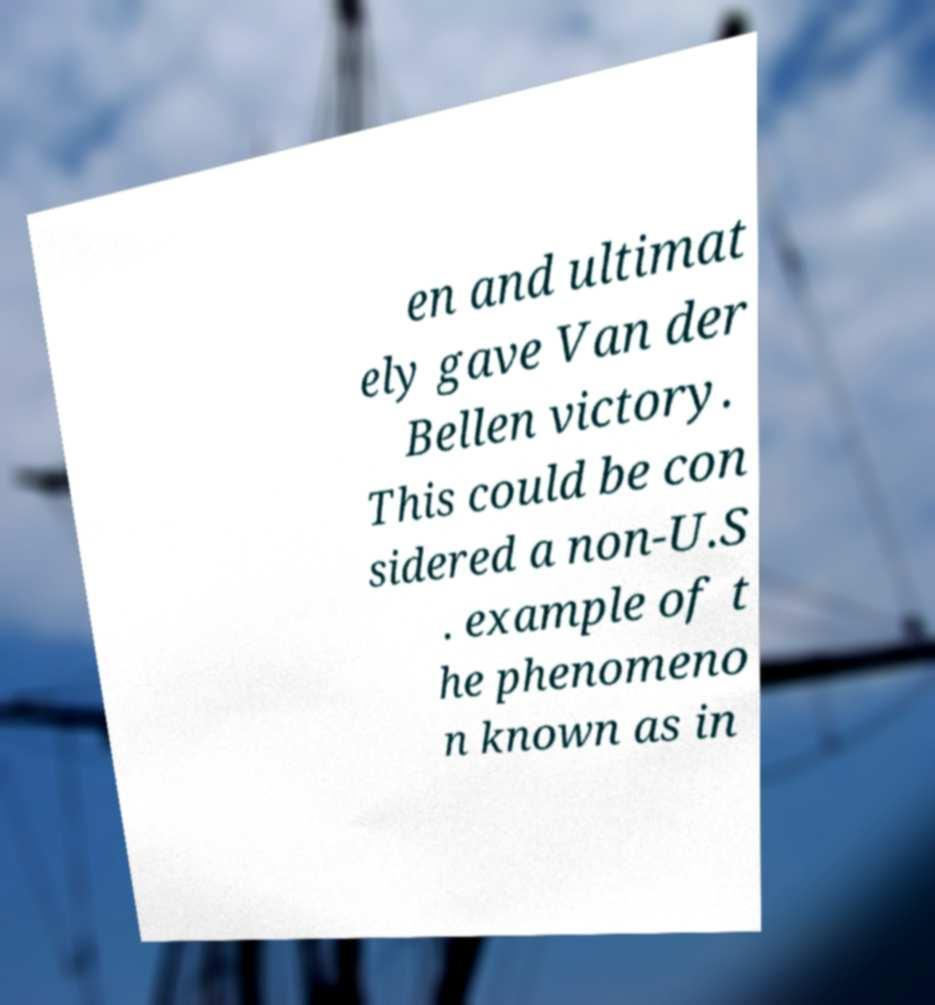Could you extract and type out the text from this image? en and ultimat ely gave Van der Bellen victory. This could be con sidered a non-U.S . example of t he phenomeno n known as in 